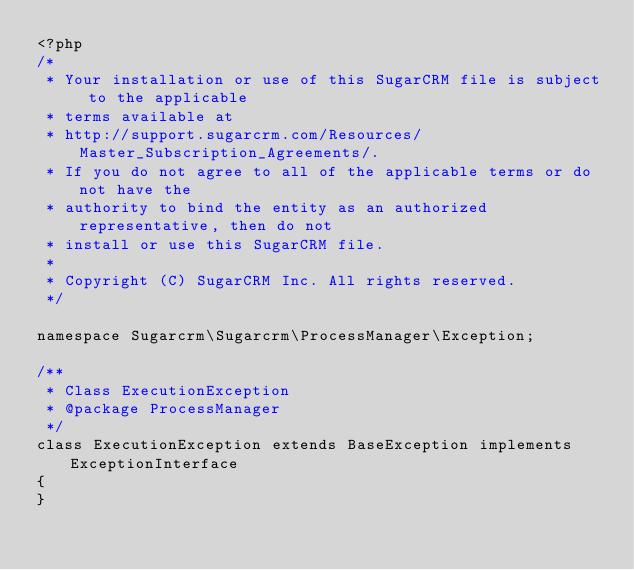Convert code to text. <code><loc_0><loc_0><loc_500><loc_500><_PHP_><?php
/*
 * Your installation or use of this SugarCRM file is subject to the applicable
 * terms available at
 * http://support.sugarcrm.com/Resources/Master_Subscription_Agreements/.
 * If you do not agree to all of the applicable terms or do not have the
 * authority to bind the entity as an authorized representative, then do not
 * install or use this SugarCRM file.
 *
 * Copyright (C) SugarCRM Inc. All rights reserved.
 */

namespace Sugarcrm\Sugarcrm\ProcessManager\Exception;

/**
 * Class ExecutionException
 * @package ProcessManager
 */
class ExecutionException extends BaseException implements ExceptionInterface
{
}
</code> 